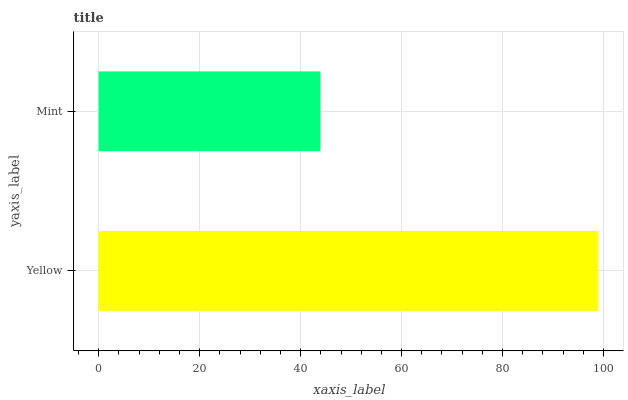Is Mint the minimum?
Answer yes or no. Yes. Is Yellow the maximum?
Answer yes or no. Yes. Is Mint the maximum?
Answer yes or no. No. Is Yellow greater than Mint?
Answer yes or no. Yes. Is Mint less than Yellow?
Answer yes or no. Yes. Is Mint greater than Yellow?
Answer yes or no. No. Is Yellow less than Mint?
Answer yes or no. No. Is Yellow the high median?
Answer yes or no. Yes. Is Mint the low median?
Answer yes or no. Yes. Is Mint the high median?
Answer yes or no. No. Is Yellow the low median?
Answer yes or no. No. 